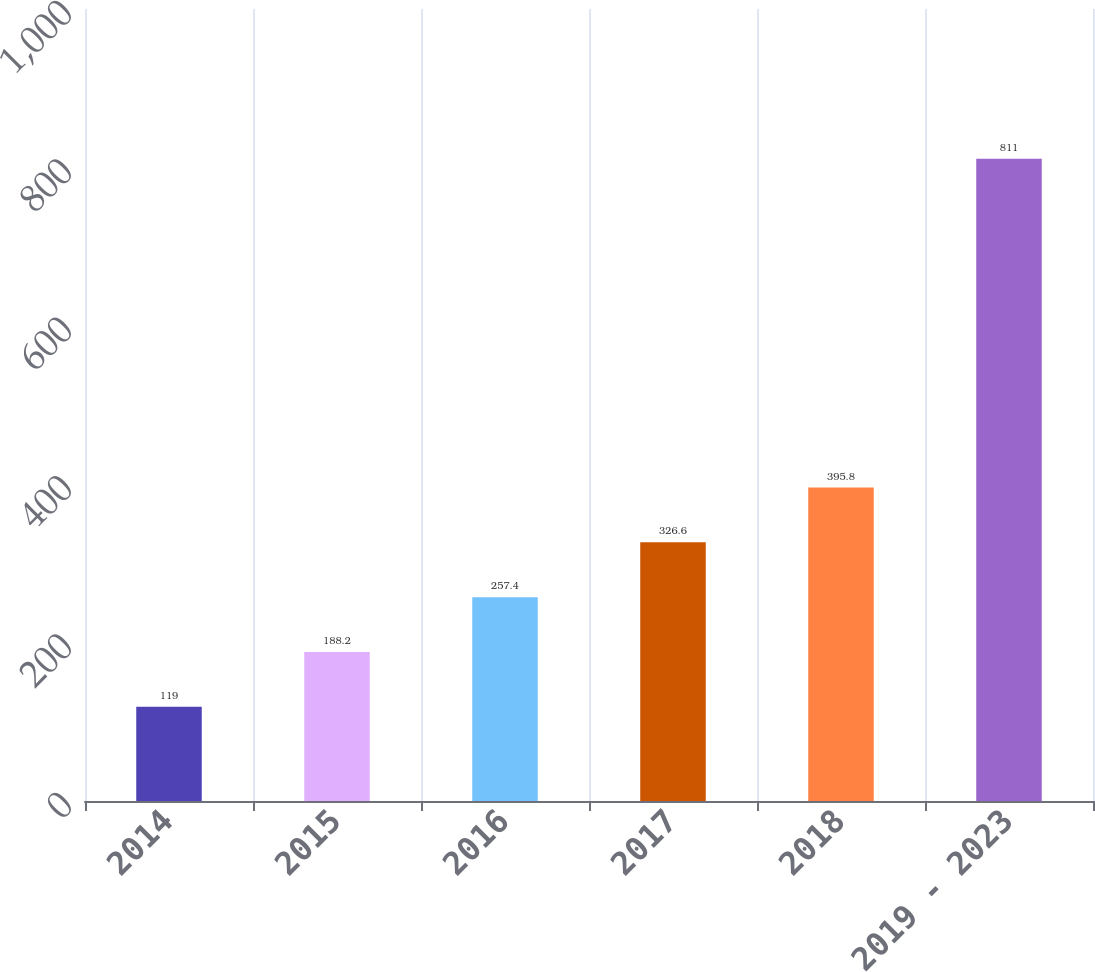Convert chart to OTSL. <chart><loc_0><loc_0><loc_500><loc_500><bar_chart><fcel>2014<fcel>2015<fcel>2016<fcel>2017<fcel>2018<fcel>2019 - 2023<nl><fcel>119<fcel>188.2<fcel>257.4<fcel>326.6<fcel>395.8<fcel>811<nl></chart> 